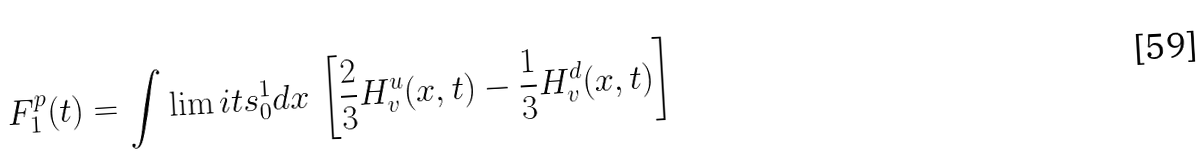Convert formula to latex. <formula><loc_0><loc_0><loc_500><loc_500>F _ { 1 } ^ { p } ( t ) = \int \lim i t s _ { 0 } ^ { 1 } d x \, \left [ \frac { 2 } { 3 } H _ { v } ^ { u } ( x , t ) - \frac { 1 } { 3 } H _ { v } ^ { d } ( x , t ) \right ]</formula> 